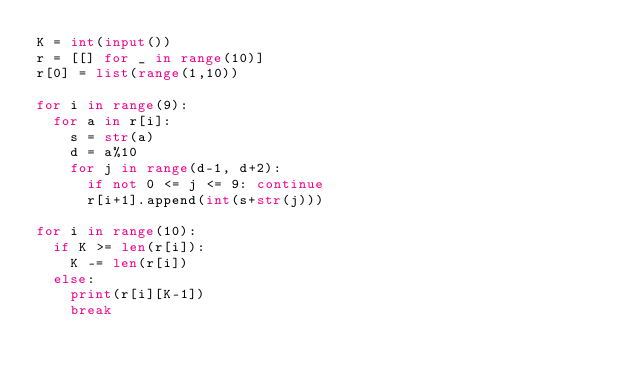Convert code to text. <code><loc_0><loc_0><loc_500><loc_500><_Python_>K = int(input())
r = [[] for _ in range(10)]
r[0] = list(range(1,10))

for i in range(9):
  for a in r[i]:
    s = str(a)
    d = a%10
    for j in range(d-1, d+2):
      if not 0 <= j <= 9: continue
      r[i+1].append(int(s+str(j)))

for i in range(10):
  if K >= len(r[i]):
    K -= len(r[i])
  else:
    print(r[i][K-1])
    break</code> 